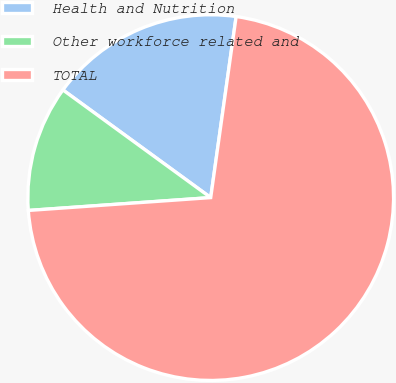<chart> <loc_0><loc_0><loc_500><loc_500><pie_chart><fcel>Health and Nutrition<fcel>Other workforce related and<fcel>TOTAL<nl><fcel>17.2%<fcel>11.14%<fcel>71.66%<nl></chart> 